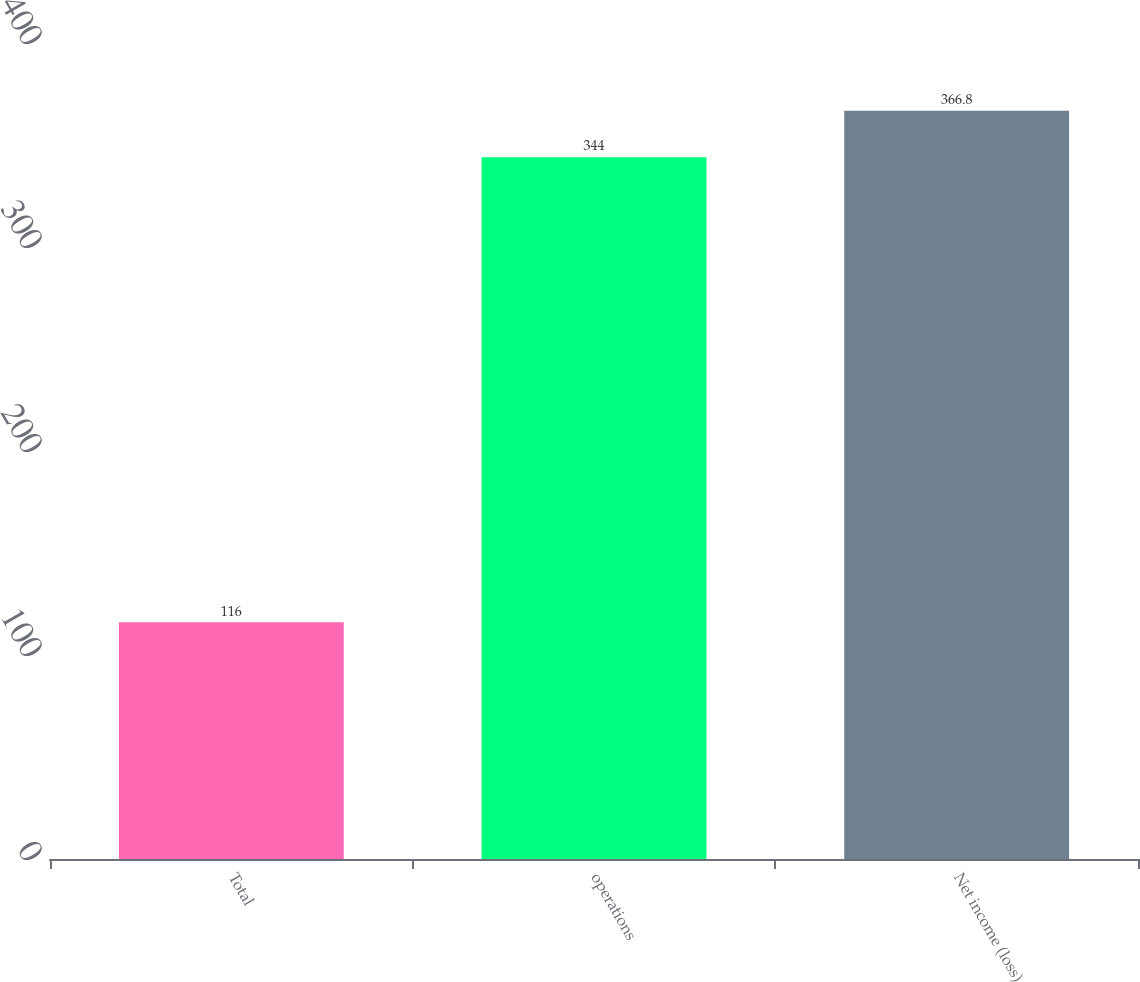Convert chart. <chart><loc_0><loc_0><loc_500><loc_500><bar_chart><fcel>Total<fcel>operations<fcel>Net income (loss)<nl><fcel>116<fcel>344<fcel>366.8<nl></chart> 